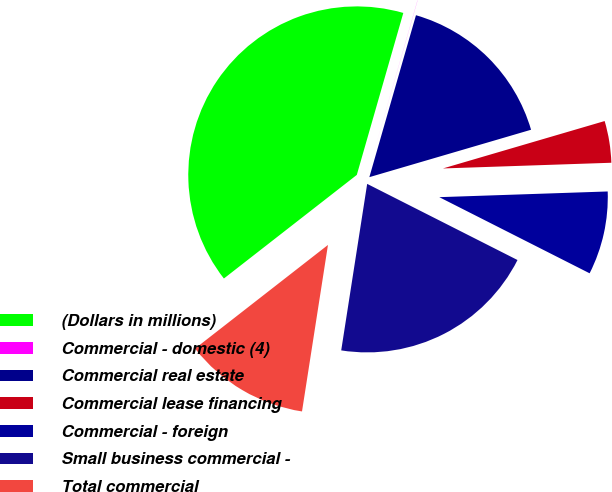Convert chart. <chart><loc_0><loc_0><loc_500><loc_500><pie_chart><fcel>(Dollars in millions)<fcel>Commercial - domestic (4)<fcel>Commercial real estate<fcel>Commercial lease financing<fcel>Commercial - foreign<fcel>Small business commercial -<fcel>Total commercial<nl><fcel>39.99%<fcel>0.01%<fcel>16.0%<fcel>4.0%<fcel>8.0%<fcel>20.0%<fcel>12.0%<nl></chart> 